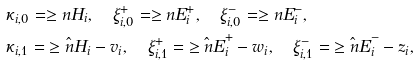Convert formula to latex. <formula><loc_0><loc_0><loc_500><loc_500>& \kappa _ { i , 0 } = \geq n { H } _ { i } , \quad \xi ^ { + } _ { i , 0 } = \geq n { E } ^ { + } _ { i } , \quad \xi ^ { - } _ { i , 0 } = \geq n { E } ^ { - } _ { i } , \\ & \kappa _ { i , 1 } = \hat { \geq n { H } } _ { i } - v _ { i } , \quad \xi ^ { + } _ { i , 1 } = \hat { \geq n { E } } ^ { + } _ { i } - w _ { i } , \quad \xi ^ { - } _ { i , 1 } = \hat { \geq n { E } } ^ { - } _ { i } - z _ { i } ,</formula> 